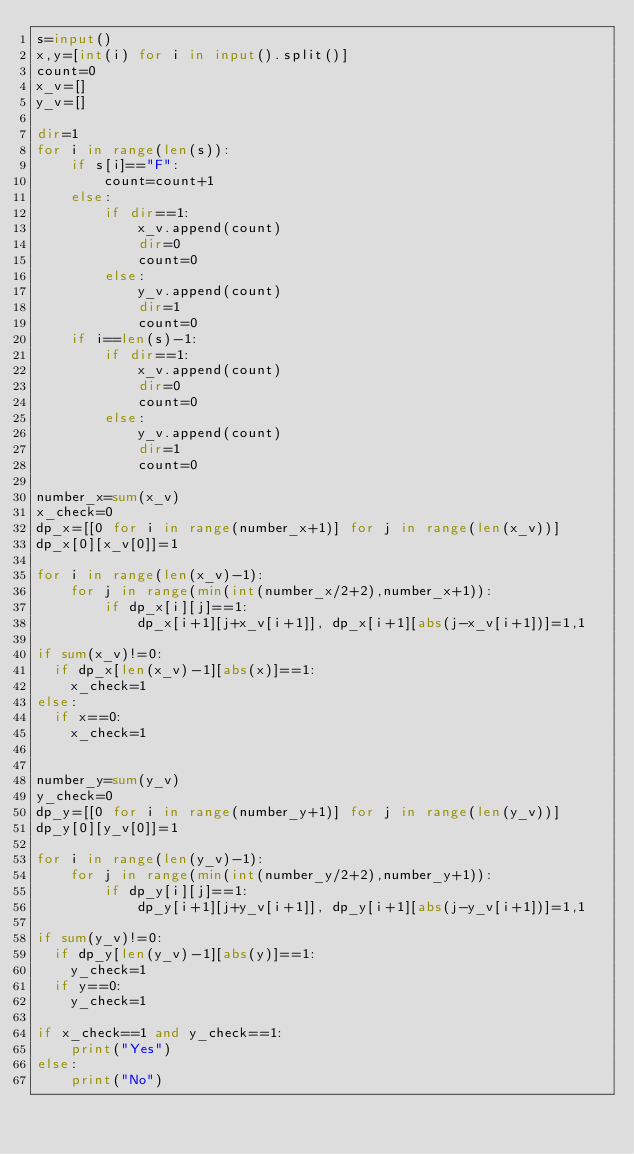Convert code to text. <code><loc_0><loc_0><loc_500><loc_500><_Python_>s=input()
x,y=[int(i) for i in input().split()]
count=0
x_v=[]
y_v=[]

dir=1
for i in range(len(s)):
    if s[i]=="F":
        count=count+1
    else:
        if dir==1:
            x_v.append(count)
            dir=0
            count=0
        else:
            y_v.append(count)
            dir=1
            count=0
    if i==len(s)-1:
        if dir==1:
            x_v.append(count)
            dir=0
            count=0
        else:
            y_v.append(count)
            dir=1
            count=0        

number_x=sum(x_v)
x_check=0
dp_x=[[0 for i in range(number_x+1)] for j in range(len(x_v))]
dp_x[0][x_v[0]]=1

for i in range(len(x_v)-1):
    for j in range(min(int(number_x/2+2),number_x+1)):
        if dp_x[i][j]==1:
            dp_x[i+1][j+x_v[i+1]], dp_x[i+1][abs(j-x_v[i+1])]=1,1

if sum(x_v)!=0:
  if dp_x[len(x_v)-1][abs(x)]==1:
    x_check=1
else:
  if x==0:
    x_check=1  


number_y=sum(y_v)
y_check=0
dp_y=[[0 for i in range(number_y+1)] for j in range(len(y_v))]
dp_y[0][y_v[0]]=1

for i in range(len(y_v)-1):
    for j in range(min(int(number_y/2+2),number_y+1)):
        if dp_y[i][j]==1:
            dp_y[i+1][j+y_v[i+1]], dp_y[i+1][abs(j-y_v[i+1])]=1,1

if sum(y_v)!=0:
  if dp_y[len(y_v)-1][abs(y)]==1:
    y_check=1
  if y==0:
    y_check=1

if x_check==1 and y_check==1:
    print("Yes")
else:
    print("No")</code> 